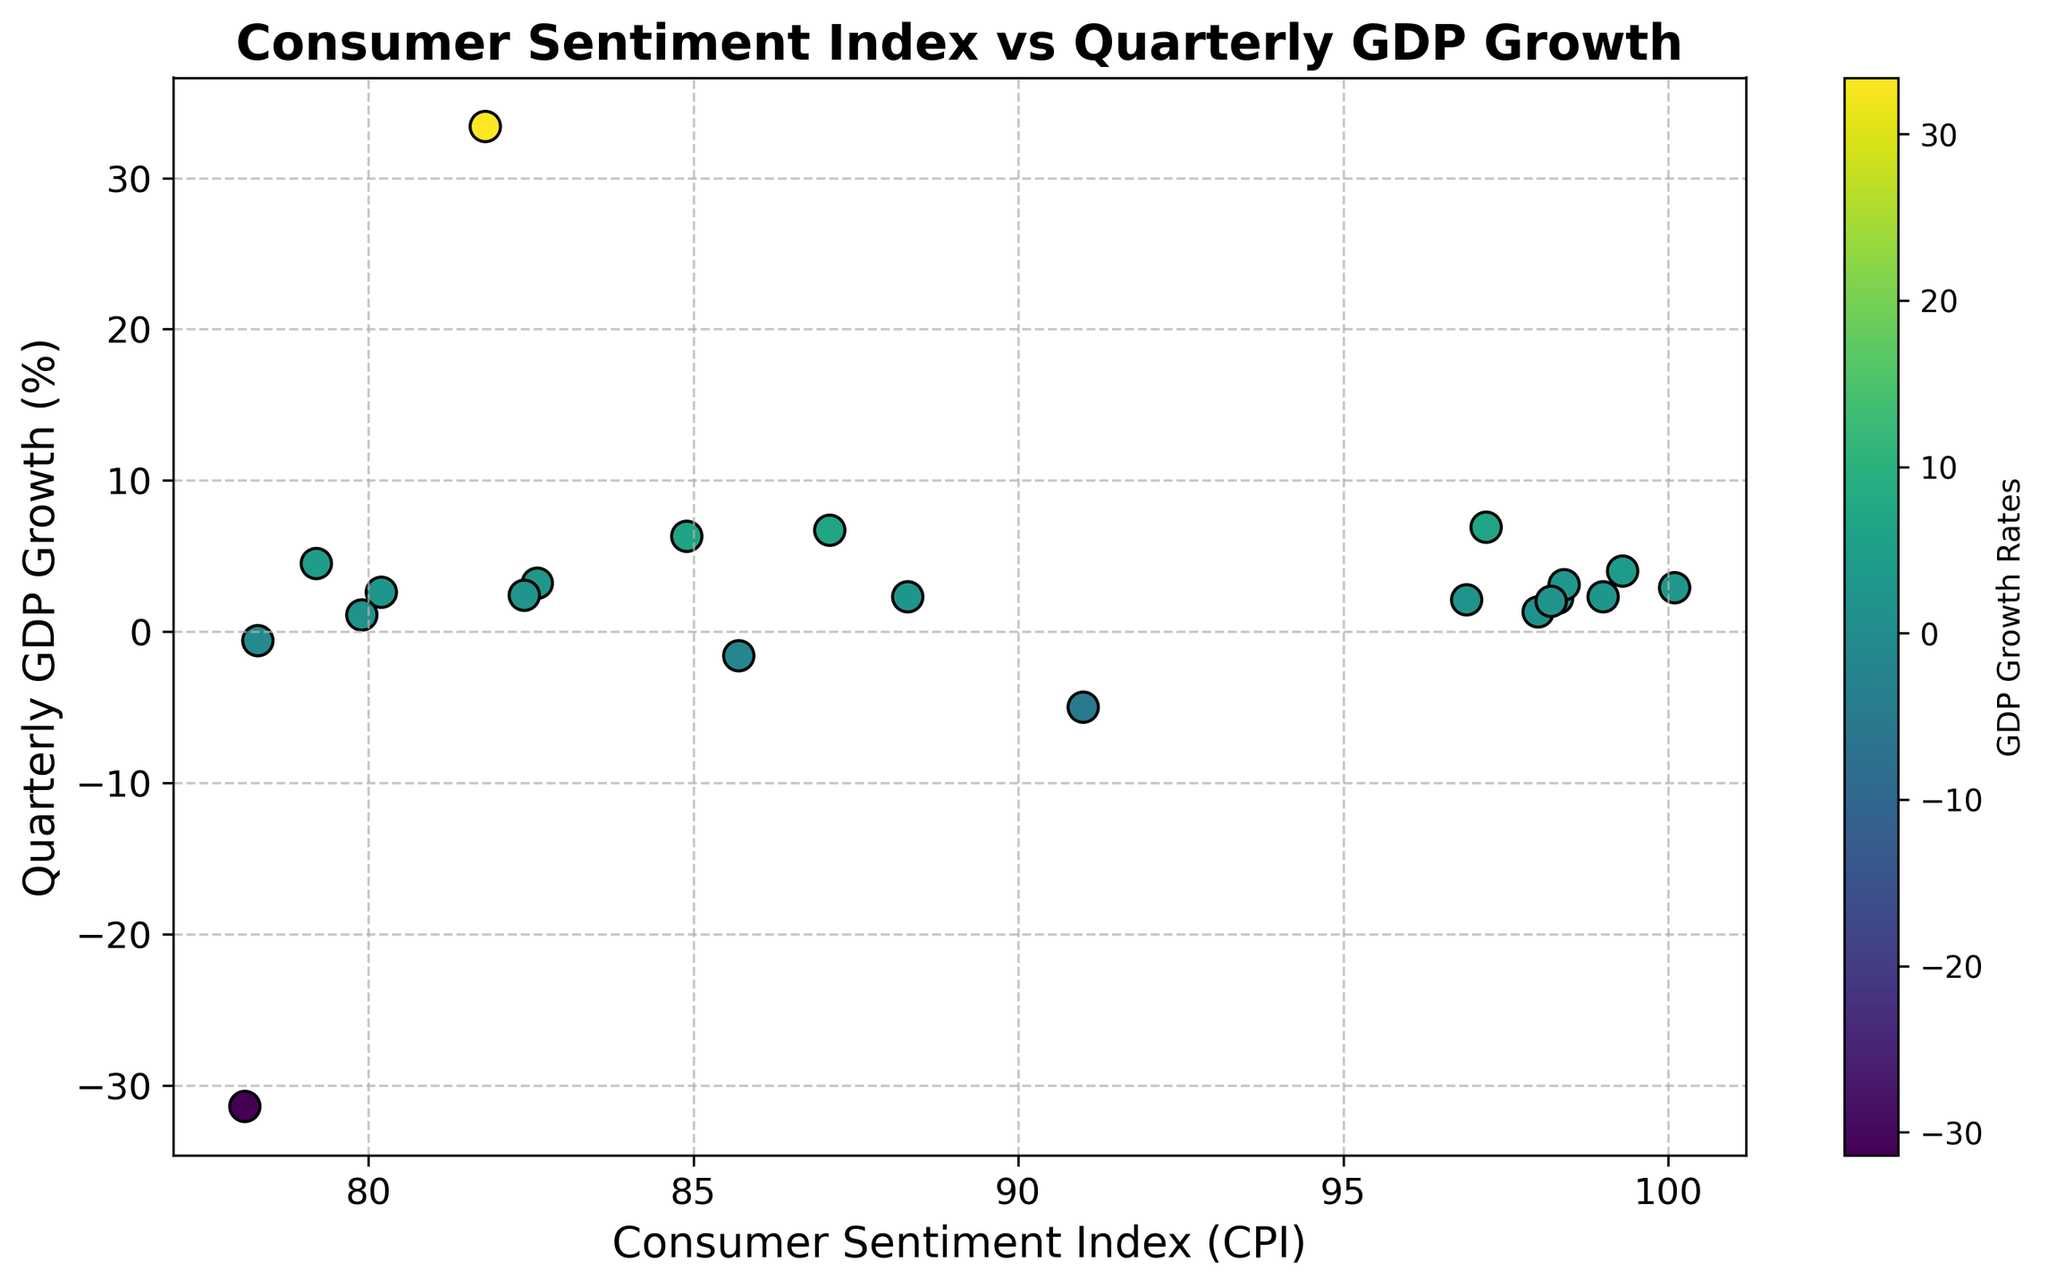What is the average GDP growth rate for the points in the scatter plot? The GDP growth rates are: 2.2, 4.0, 2.9, 1.3, 3.1, 2.0, 2.1, 2.3, -5.0, -31.4, 33.4, 4.5, 6.3, 6.7, 2.3, 6.9, -1.6, -0.6, 3.2, 2.6, 1.1, 2.4. Adding them up gives 45.4. There are 22 points, so the average is 45.4 / 22
Answer: 2.06 Which quarter has the lowest GDP growth rate, and what is its Consumer Sentiment Index? The lowest GDP growth rate is -31.4 in 2020-Q2. According to the scatter plot, the corresponding CPI is 78.1
Answer: 2020-Q2, 78.1 Is there a general trend of how the Consumer Sentiment Index relates to GDP growth rates? By observing the scatter plot, we can see that higher CPI values generally correspond to positive GDP growth rates, and lower CPI values correspond to negative GDP growth rates. This indicates a positive correlation between CPI and GDP growth rates
Answer: Positive correlation What is the GDP growth rate at CPI 79.2 and how does it visually compare to the GDP growth rate at CPI 78.1? CPI 79.2 corresponds to GDP growth rate 4.5, and CPI 78.1 corresponds to GDP growth rate -31.4. Comparing visually on the scatter plot, GDP growth at 79.2 is significantly higher than at 78.1
Answer: 4.5, much higher How many quarters had a negative GDP growth rate and what is the range of their CPI values? There are 4 quarters with a negative GDP growth rate: 2020-Q1 (-5.0), 2020-Q2 (-31.4), 2022-Q1 (-1.6), and 2022-Q2 (-0.6). Their corresponding CPI values range from 78.1 to 91.0
Answer: 4 quarters, 78.1-91.0 What is the cumulative sum of GDP growth rates for the quarters in 2020 based on the scatter plot? The GDP growth rates for 2020 are -5.0, -31.4, 33.4, 4.5. Summing these gives -5.0 + (-31.4) + 33.4 + 4.5 = 1.5
Answer: 1.5 Which quarter has the highest GDP growth rate, and how does its CPI compare to the CPI of the quarter with the lowest GDP growth rate? The highest GDP growth rate is 33.4 in 2020-Q3 with a CPI of 81.8. The lowest is -31.4 in 2020-Q2 with a CPI of 78.1. The CPI of the highest GDP growth rate quarter is higher than that of the lowest
Answer: 2020-Q3, 81.8, higher Are there more quarters with a GDP growth rate greater than 2% or less than 2%? By observing the scatter plot, there are 12 quarters with GDP growth rates greater than 2% and 10 quarters with less than 2% (including the negatives)
Answer: More with greater than 2% What is the GDP growth rate at the highest CPI value and at the lowest CPI value? The highest CPI value is 100.1 with GDP growth of 2.9, and the lowest CPI value is 78.1 with GDP growth of -31.4
Answer: 2.9, -31.4 